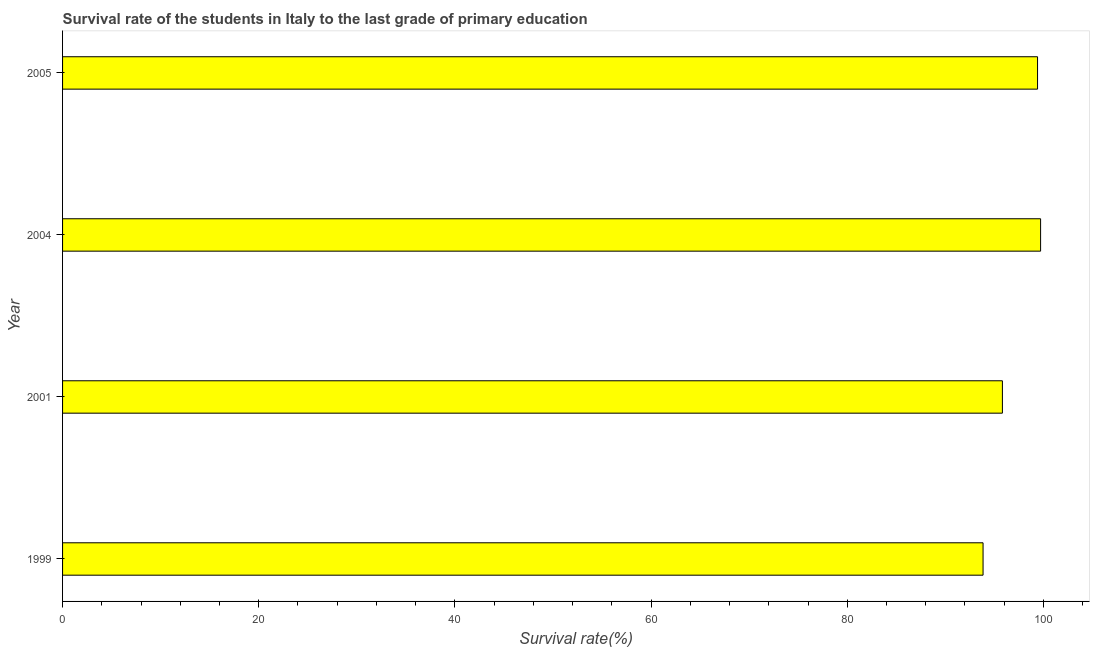Does the graph contain any zero values?
Your response must be concise. No. Does the graph contain grids?
Offer a very short reply. No. What is the title of the graph?
Ensure brevity in your answer.  Survival rate of the students in Italy to the last grade of primary education. What is the label or title of the X-axis?
Provide a short and direct response. Survival rate(%). What is the survival rate in primary education in 2005?
Your answer should be very brief. 99.4. Across all years, what is the maximum survival rate in primary education?
Provide a succinct answer. 99.71. Across all years, what is the minimum survival rate in primary education?
Give a very brief answer. 93.85. What is the sum of the survival rate in primary education?
Ensure brevity in your answer.  388.78. What is the difference between the survival rate in primary education in 1999 and 2004?
Your answer should be very brief. -5.87. What is the average survival rate in primary education per year?
Ensure brevity in your answer.  97.19. What is the median survival rate in primary education?
Offer a terse response. 97.61. In how many years, is the survival rate in primary education greater than 12 %?
Ensure brevity in your answer.  4. What is the ratio of the survival rate in primary education in 2001 to that in 2005?
Your response must be concise. 0.96. What is the difference between the highest and the second highest survival rate in primary education?
Offer a terse response. 0.31. What is the difference between the highest and the lowest survival rate in primary education?
Ensure brevity in your answer.  5.87. How many years are there in the graph?
Keep it short and to the point. 4. Are the values on the major ticks of X-axis written in scientific E-notation?
Give a very brief answer. No. What is the Survival rate(%) in 1999?
Provide a short and direct response. 93.85. What is the Survival rate(%) of 2001?
Provide a short and direct response. 95.82. What is the Survival rate(%) of 2004?
Offer a very short reply. 99.71. What is the Survival rate(%) of 2005?
Your answer should be compact. 99.4. What is the difference between the Survival rate(%) in 1999 and 2001?
Give a very brief answer. -1.97. What is the difference between the Survival rate(%) in 1999 and 2004?
Keep it short and to the point. -5.87. What is the difference between the Survival rate(%) in 1999 and 2005?
Keep it short and to the point. -5.56. What is the difference between the Survival rate(%) in 2001 and 2004?
Give a very brief answer. -3.89. What is the difference between the Survival rate(%) in 2001 and 2005?
Offer a terse response. -3.58. What is the difference between the Survival rate(%) in 2004 and 2005?
Keep it short and to the point. 0.31. What is the ratio of the Survival rate(%) in 1999 to that in 2004?
Your answer should be very brief. 0.94. What is the ratio of the Survival rate(%) in 1999 to that in 2005?
Provide a short and direct response. 0.94. What is the ratio of the Survival rate(%) in 2001 to that in 2004?
Ensure brevity in your answer.  0.96. What is the ratio of the Survival rate(%) in 2004 to that in 2005?
Offer a very short reply. 1. 